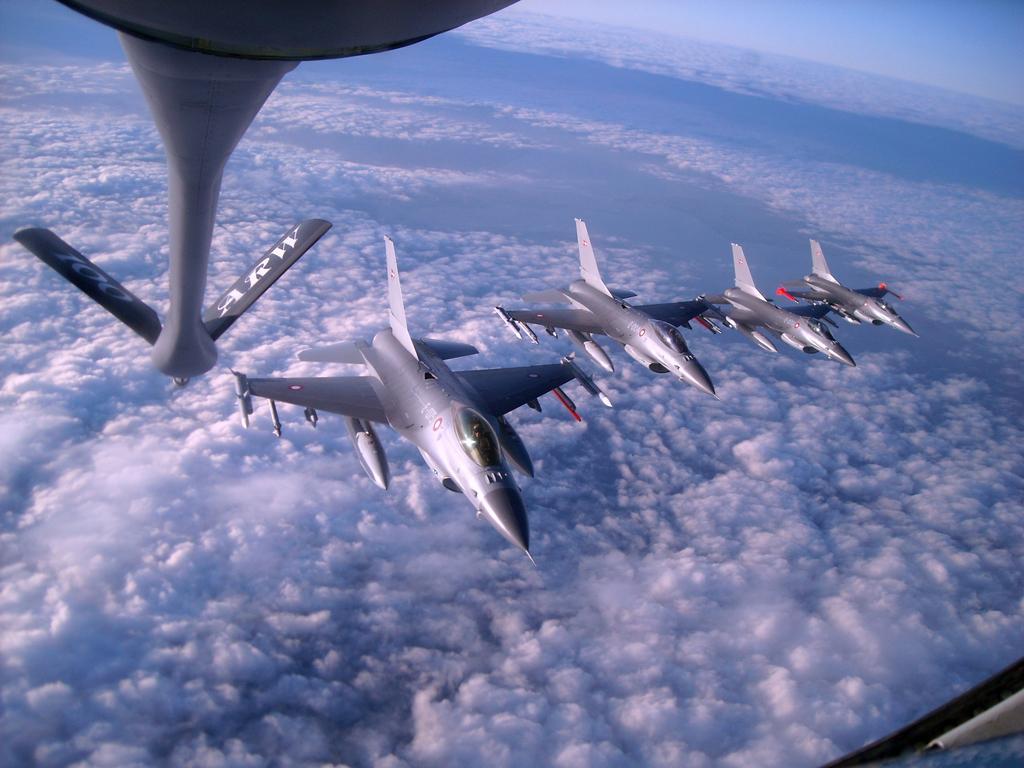Please provide a concise description of this image. There are aircraft in the sky in the foreground area of the image. 